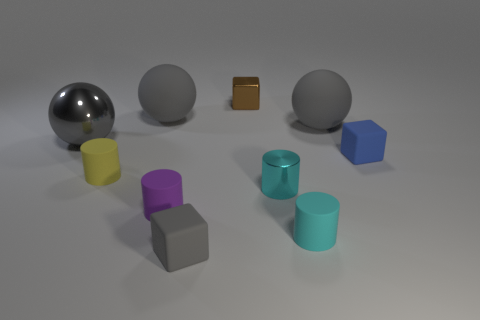Subtract all small matte cubes. How many cubes are left? 1 Subtract all yellow cylinders. How many cylinders are left? 3 Subtract all purple spheres. How many cyan cylinders are left? 2 Subtract 0 red balls. How many objects are left? 10 Subtract all cylinders. How many objects are left? 6 Subtract all red blocks. Subtract all red cylinders. How many blocks are left? 3 Subtract all small purple rubber cylinders. Subtract all tiny brown metallic blocks. How many objects are left? 8 Add 6 small rubber cubes. How many small rubber cubes are left? 8 Add 6 purple cylinders. How many purple cylinders exist? 7 